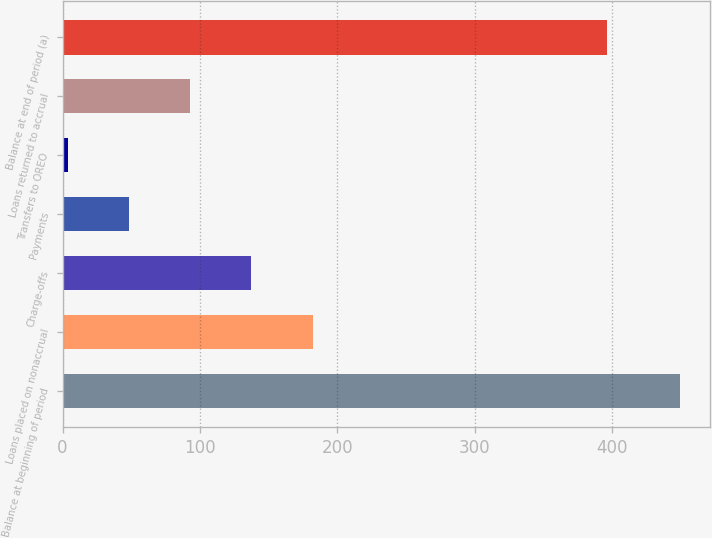<chart> <loc_0><loc_0><loc_500><loc_500><bar_chart><fcel>Balance at beginning of period<fcel>Loans placed on nonaccrual<fcel>Charge-offs<fcel>Payments<fcel>Transfers to OREO<fcel>Loans returned to accrual<fcel>Balance at end of period (a)<nl><fcel>449<fcel>182<fcel>137.5<fcel>48.5<fcel>4<fcel>93<fcel>396<nl></chart> 